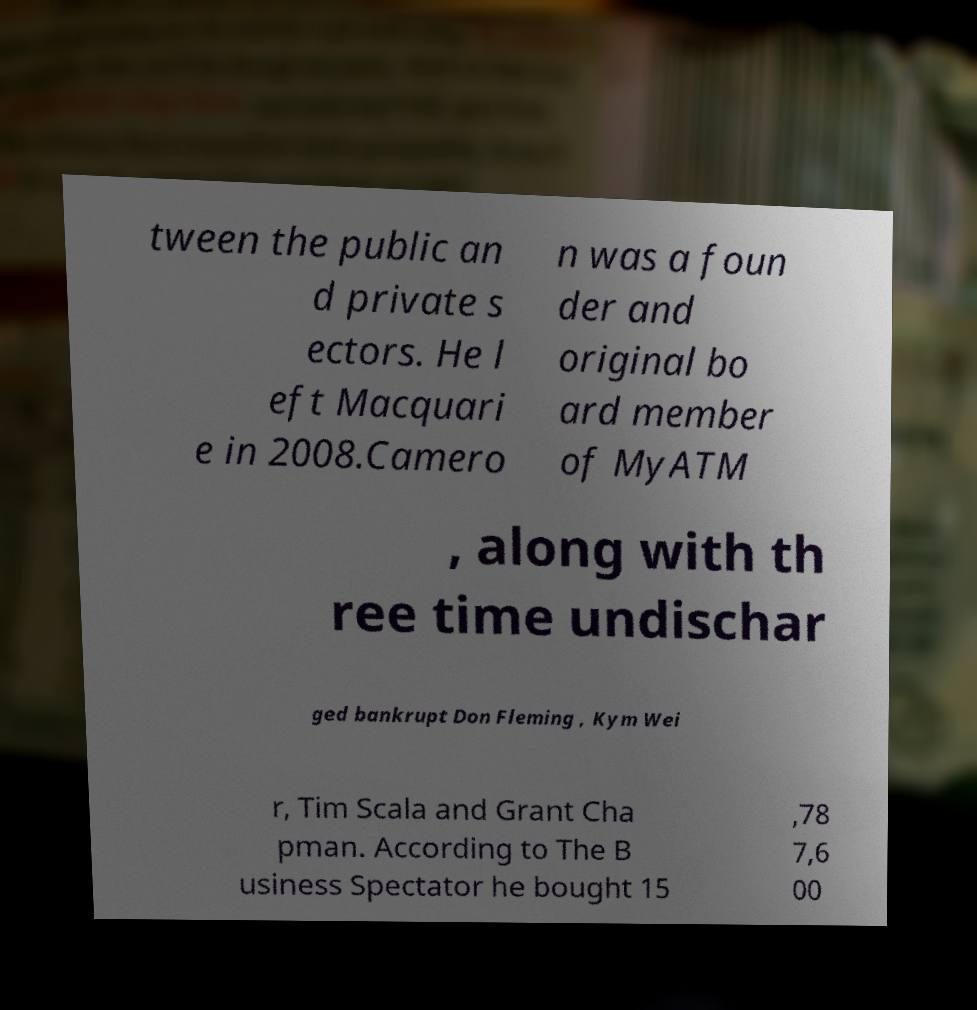Please identify and transcribe the text found in this image. tween the public an d private s ectors. He l eft Macquari e in 2008.Camero n was a foun der and original bo ard member of MyATM , along with th ree time undischar ged bankrupt Don Fleming , Kym Wei r, Tim Scala and Grant Cha pman. According to The B usiness Spectator he bought 15 ,78 7,6 00 